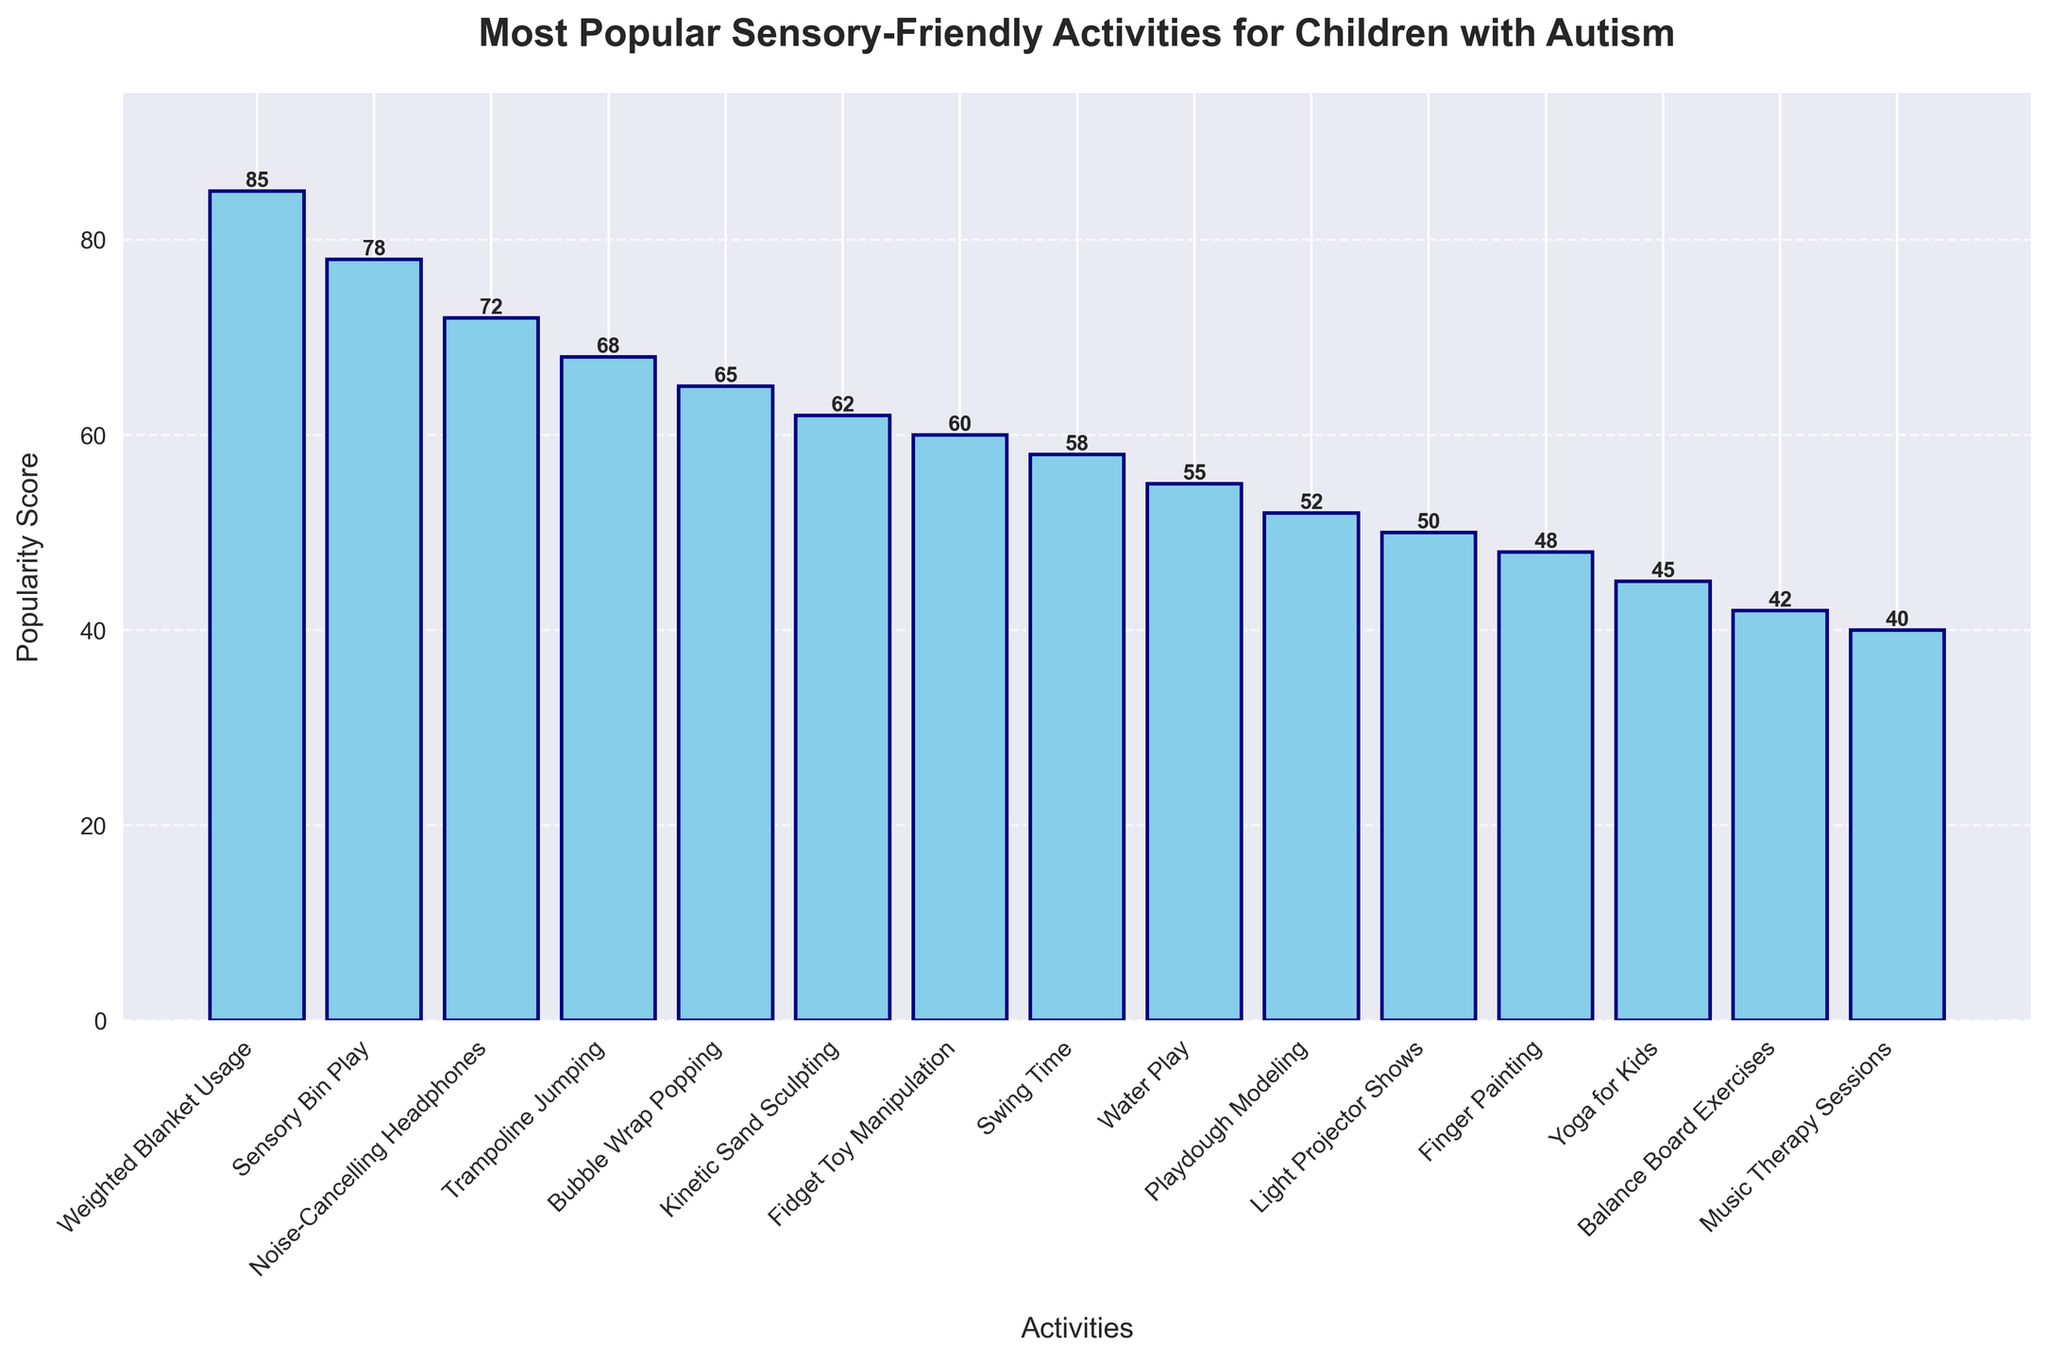What's the most popular sensory-friendly activity for children with autism? The activity with the highest bar represents the most popular activity. The bar for "Weighted Blanket Usage" is the tallest, showing a popularity score of 85.
Answer: Weighted Blanket Usage Which activity has a lower popularity score: Sensory Bin Play or Trampoline Jumping? To compare the scores, look at the heights of the bars for "Sensory Bin Play" and "Trampoline Jumping." "Sensory Bin Play" has a score of 78, while "Trampoline Jumping" has a score of 68.
Answer: Trampoline Jumping What is the difference in popularity scores between Bubble Wrap Popping and Light Projector Shows? To find the difference, subtract the score of "Light Projector Shows" (50) from "Bubble Wrap Popping" (65).
Answer: 15 What are the average popularity scores of the top 3 activities? The top 3 activities are "Weighted Blanket Usage" (85), "Sensory Bin Play" (78), and "Noise-Cancelling Headphones" (72). Add these scores to get 85 + 78 + 72 = 235. Divide by 3 to find the average: 235 / 3 ≈ 78.33.
Answer: 78.33 Is the popularity score of Fidget Toy Manipulation greater than the average score of all activities in the chart? First, calculate the average score of all activities. Add up all scores: 85 + 78 + 72 + 68 + 65 + 62 + 60 + 58 + 55 + 52 + 50 + 48 + 45 + 42 + 40 = 880. Divide by the number of activities (15): 880 / 15 ≈ 58.67. The popularity score of "Fidget Toy Manipulation" is 60. Since 60 > 58.67, it is greater.
Answer: Yes How many activities have a popularity score greater than 60? Count the bars with scores greater than 60: "Weighted Blanket Usage," "Sensory Bin Play," "Noise-Cancelling Headphones," "Trampoline Jumping," "Bubble Wrap Popping," "Kinetic Sand Sculpting." There are 6 activities.
Answer: 6 What is the combined popularity score of the bottom 5 activities? The bottom 5 activities are "Yoga for Kids" (45), "Balance Board Exercises" (42), and "Music Therapy Sessions" (40). Add these scores to get 45 + 42 + 40 = 127.
Answer: 127 